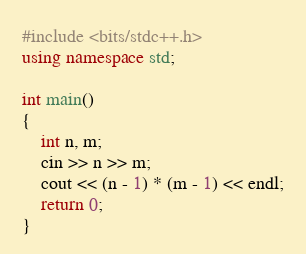<code> <loc_0><loc_0><loc_500><loc_500><_C++_>#include <bits/stdc++.h>
using namespace std;

int main()
{
	int n, m;
	cin >> n >> m;
	cout << (n - 1) * (m - 1) << endl;
	return 0;
}
</code> 